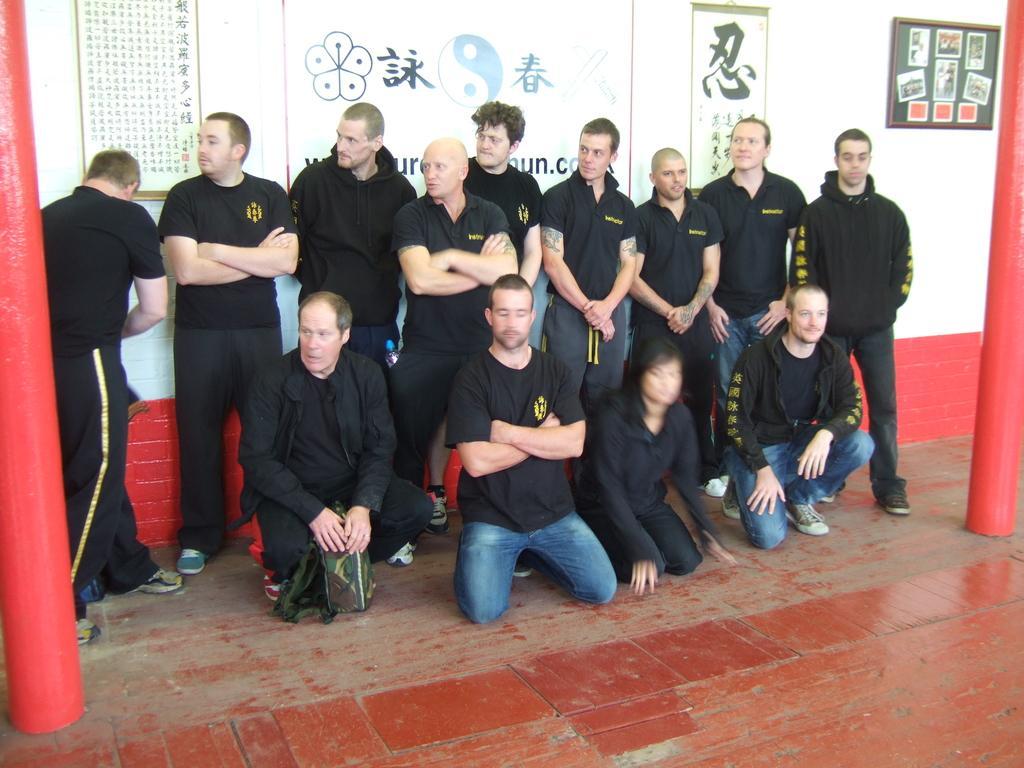Can you describe this image briefly? In this image, we can see a group of people. We can also see the ground. There are a few pillars. In the background, we can see the wall with some posters. There are some images and text on the posters. We can also see a frame on the wall. 